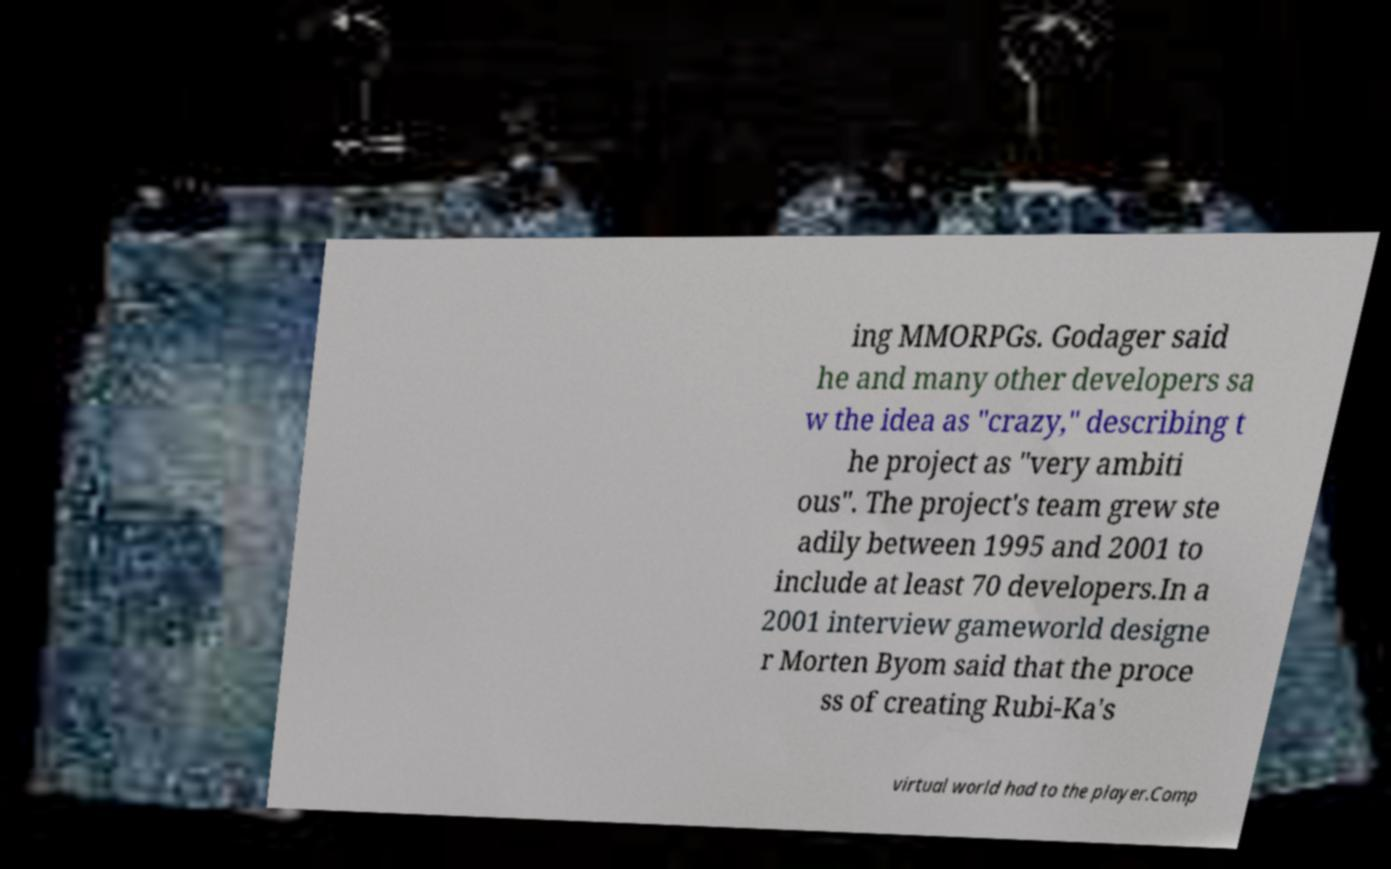I need the written content from this picture converted into text. Can you do that? ing MMORPGs. Godager said he and many other developers sa w the idea as "crazy," describing t he project as "very ambiti ous". The project's team grew ste adily between 1995 and 2001 to include at least 70 developers.In a 2001 interview gameworld designe r Morten Byom said that the proce ss of creating Rubi-Ka's virtual world had to the player.Comp 